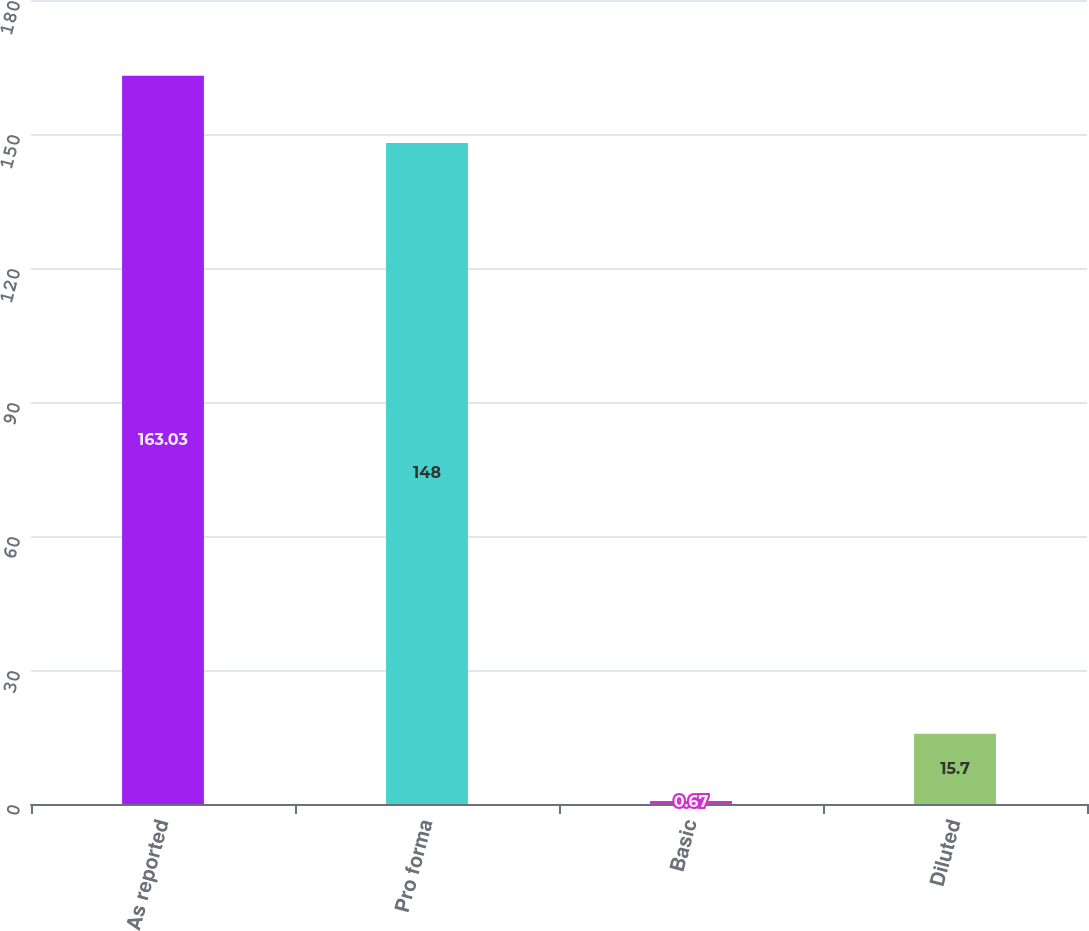Convert chart. <chart><loc_0><loc_0><loc_500><loc_500><bar_chart><fcel>As reported<fcel>Pro forma<fcel>Basic<fcel>Diluted<nl><fcel>163.03<fcel>148<fcel>0.67<fcel>15.7<nl></chart> 